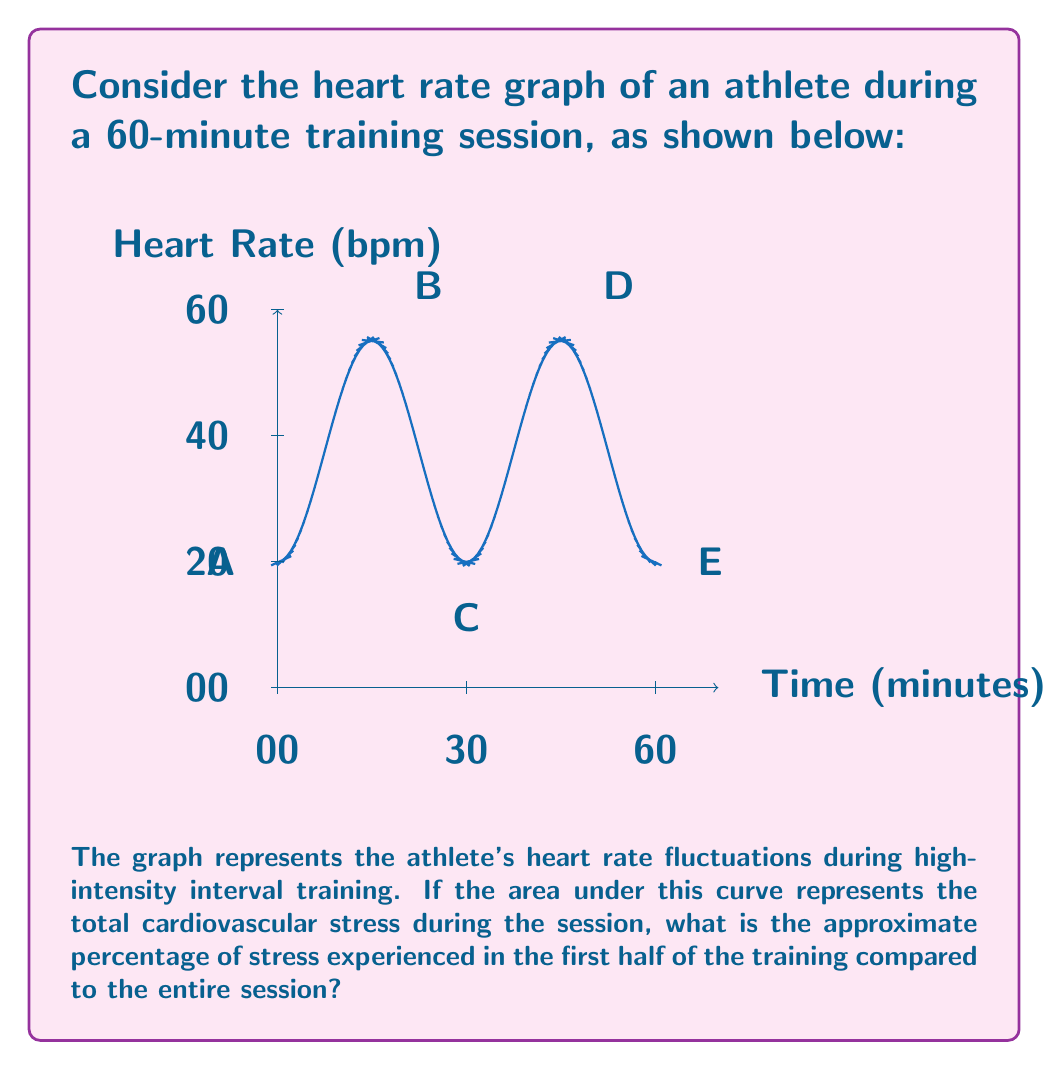Could you help me with this problem? To solve this problem, we need to estimate the area under the curve for the first half of the training (0-30 minutes) and compare it to the total area (0-60 minutes). Here's a step-by-step approach:

1) The curve appears to be symmetric, with two full cycles over the 60-minute period.

2) Each cycle peaks at 160 bpm and troughs at 60 bpm, with a period of 30 minutes.

3) We can approximate the area under the curve using the formula for the area of a trapezoid:
   $A = \frac{1}{2}(b_1 + b_2)h$

4) For one full cycle (0-30 minutes):
   Base 1 (b₁) = 60 bpm
   Base 2 (b₂) = 160 bpm
   Height (h) = 30 minutes
   $A_{\text{half}} = \frac{1}{2}(60 + 160) \times 30 = 3300$ bpm·min

5) The total area for the full 60 minutes would be twice this:
   $A_{\text{total}} = 2 \times 3300 = 6600$ bpm·min

6) To calculate the percentage, we divide the area of the first half by the total area and multiply by 100:

   $\text{Percentage} = \frac{A_{\text{half}}}{A_{\text{total}}} \times 100\% = \frac{3300}{6600} \times 100\% = 50\%$

Therefore, the stress experienced in the first half of the training is approximately 50% of the total session stress.
Answer: 50% 